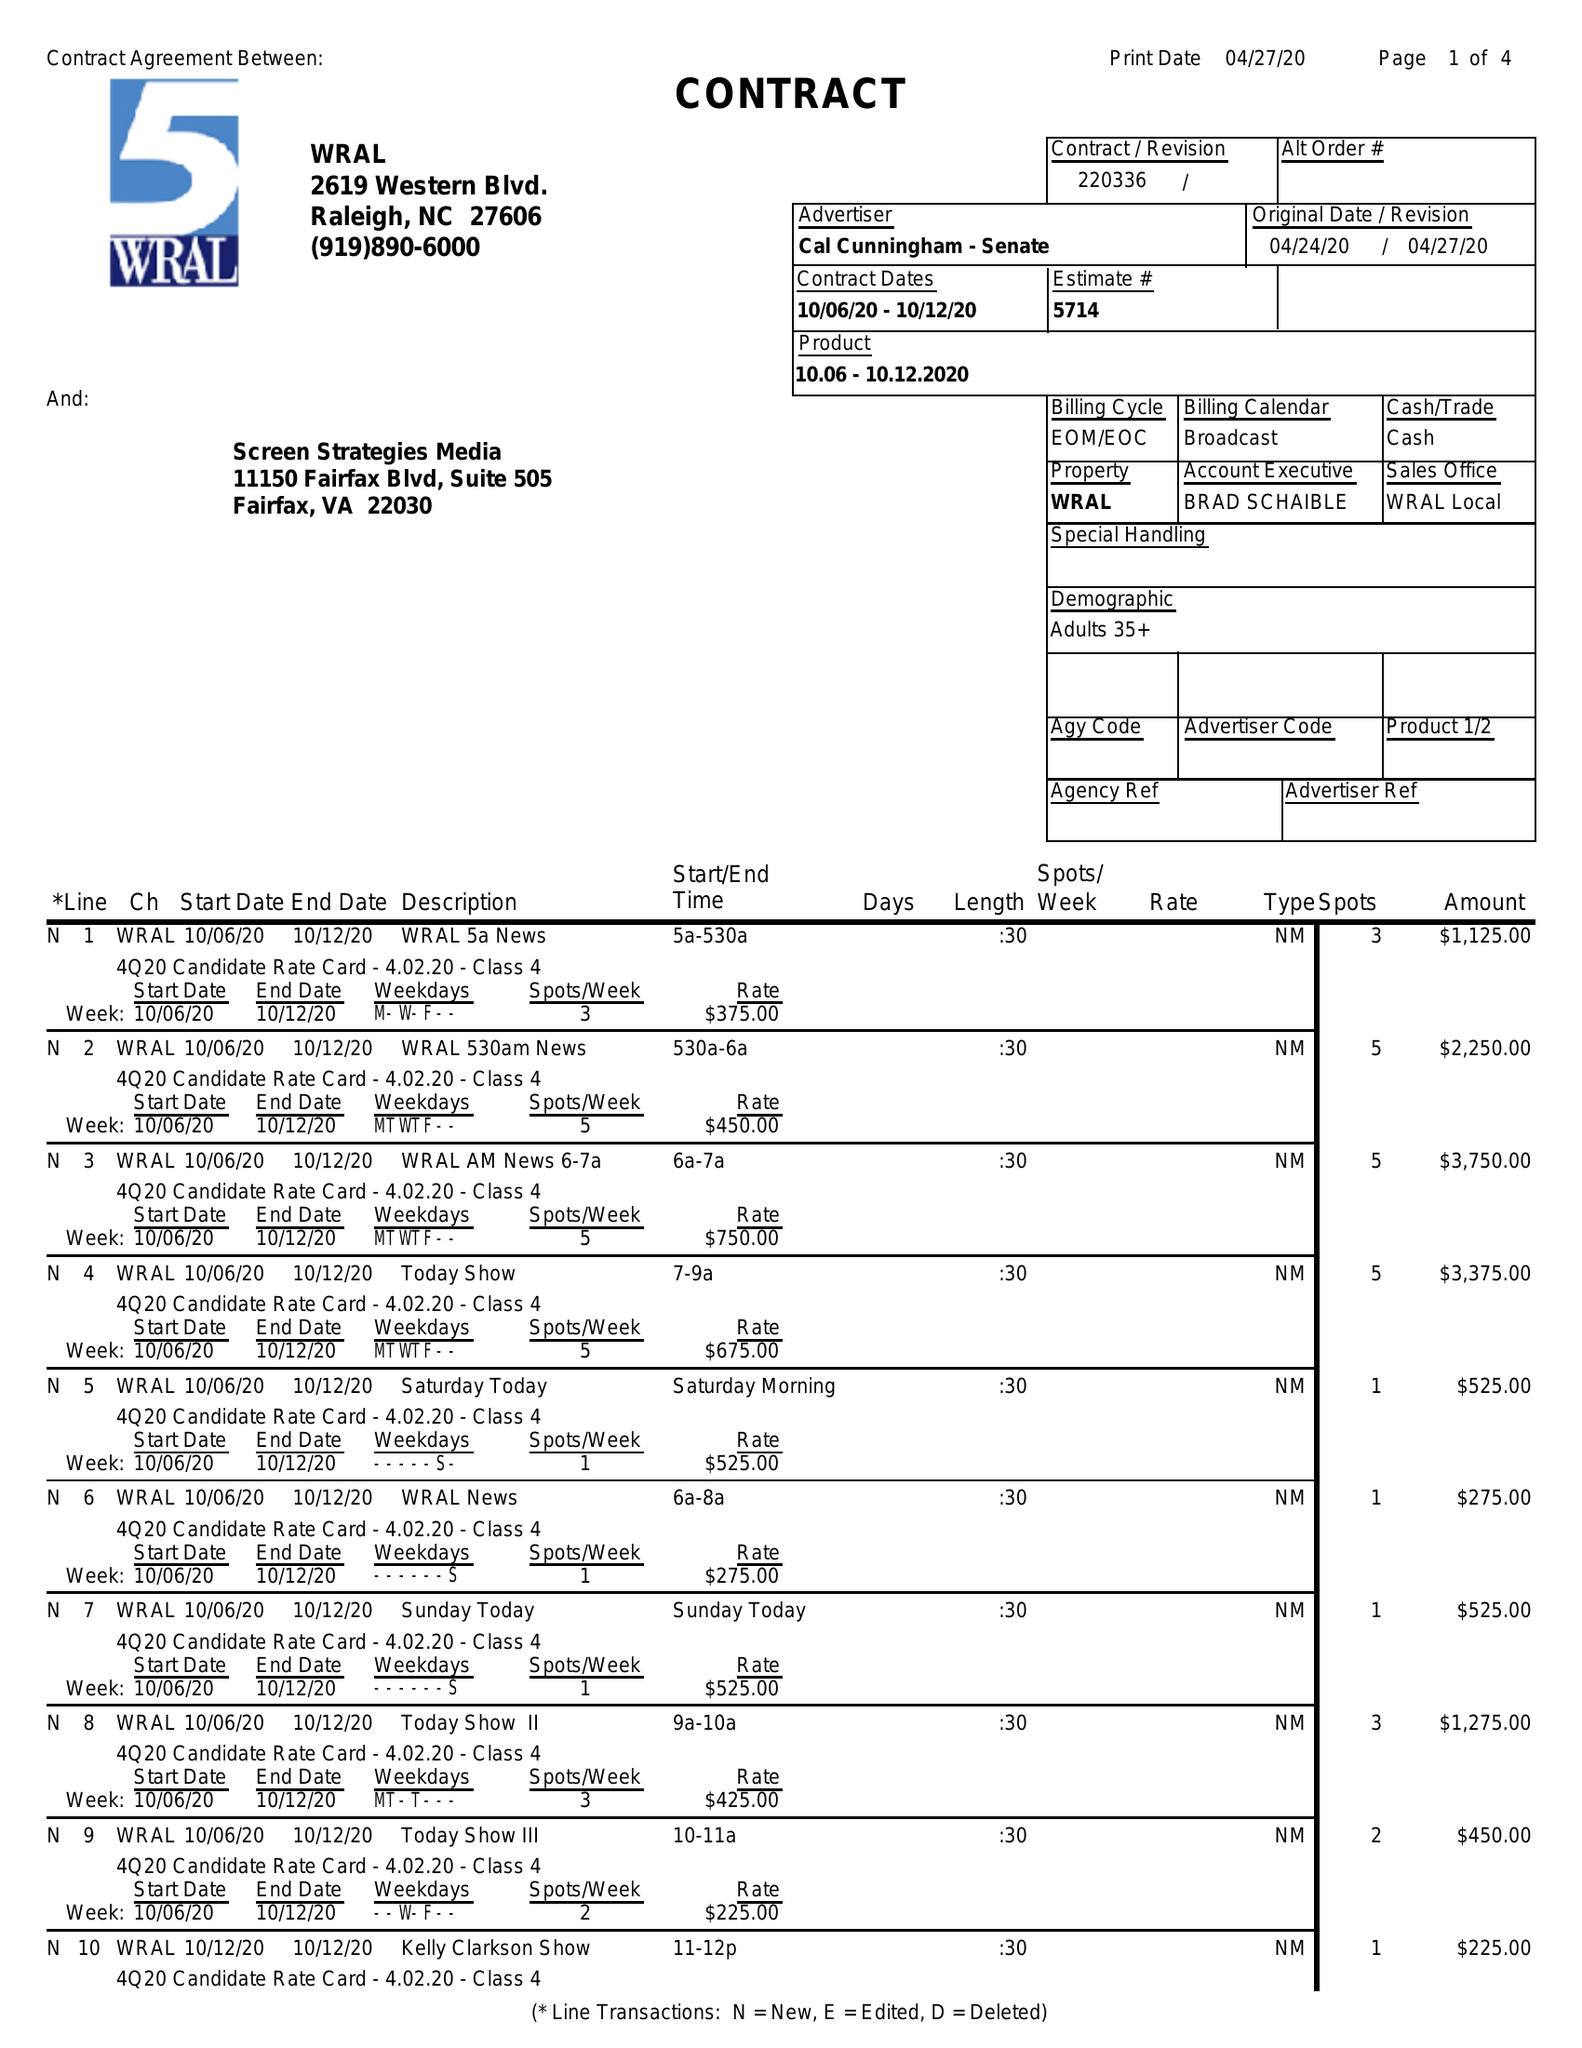What is the value for the advertiser?
Answer the question using a single word or phrase. CAL CUNNINGHAM - SENATE 